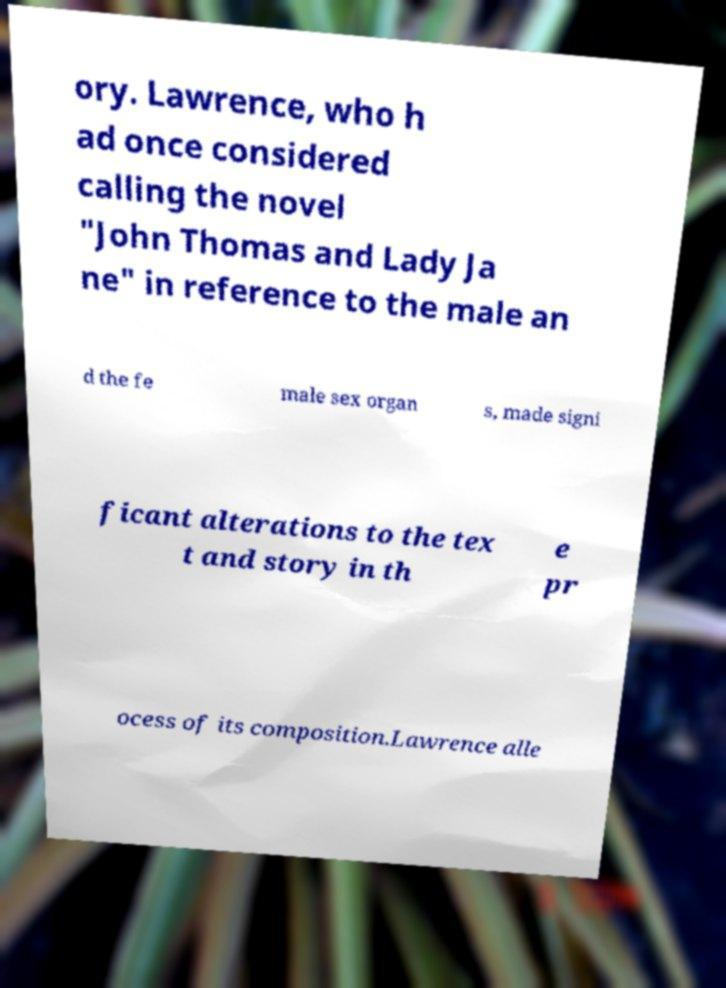Can you read and provide the text displayed in the image?This photo seems to have some interesting text. Can you extract and type it out for me? ory. Lawrence, who h ad once considered calling the novel "John Thomas and Lady Ja ne" in reference to the male an d the fe male sex organ s, made signi ficant alterations to the tex t and story in th e pr ocess of its composition.Lawrence alle 